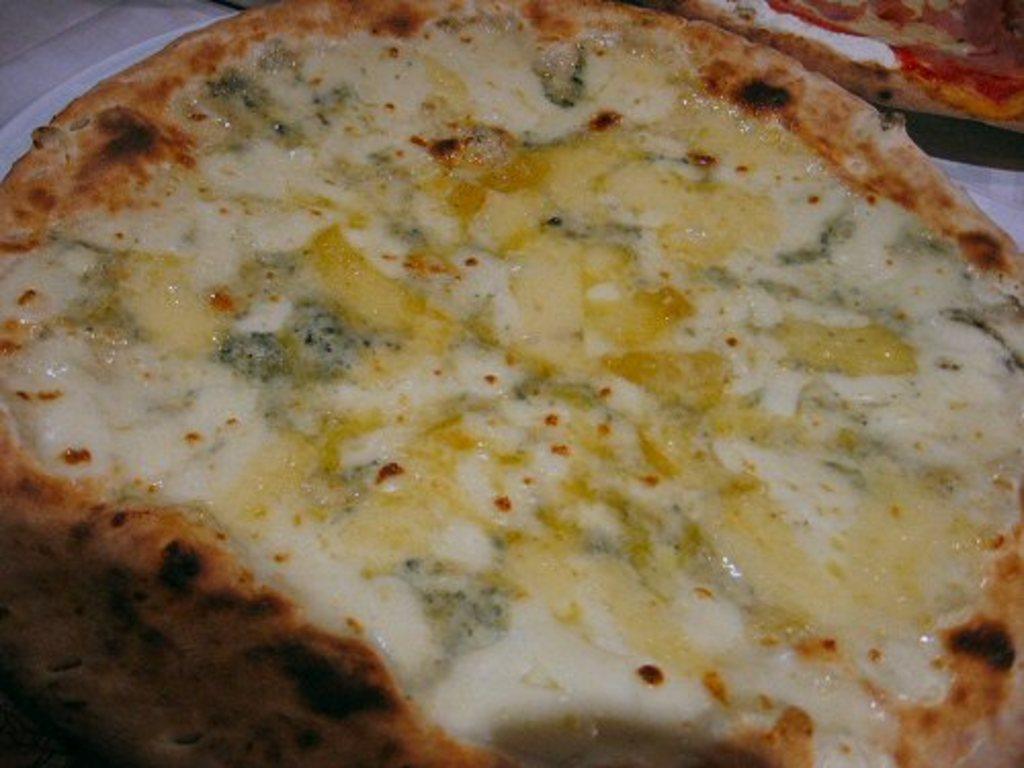How would you summarize this image in a sentence or two? In this image I can see two pizzas and on it I can see few ingredients. 